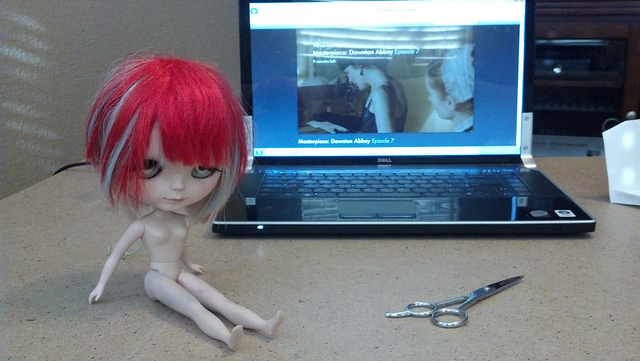Please transcribe the text information in this image. DOLL 